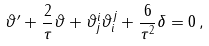<formula> <loc_0><loc_0><loc_500><loc_500>\vartheta ^ { \prime } + \frac { 2 } { \tau } \vartheta + \vartheta ^ { i } _ { j } \vartheta ^ { j } _ { i } + \frac { 6 } { \tau ^ { 2 } } \delta = 0 \, ,</formula> 